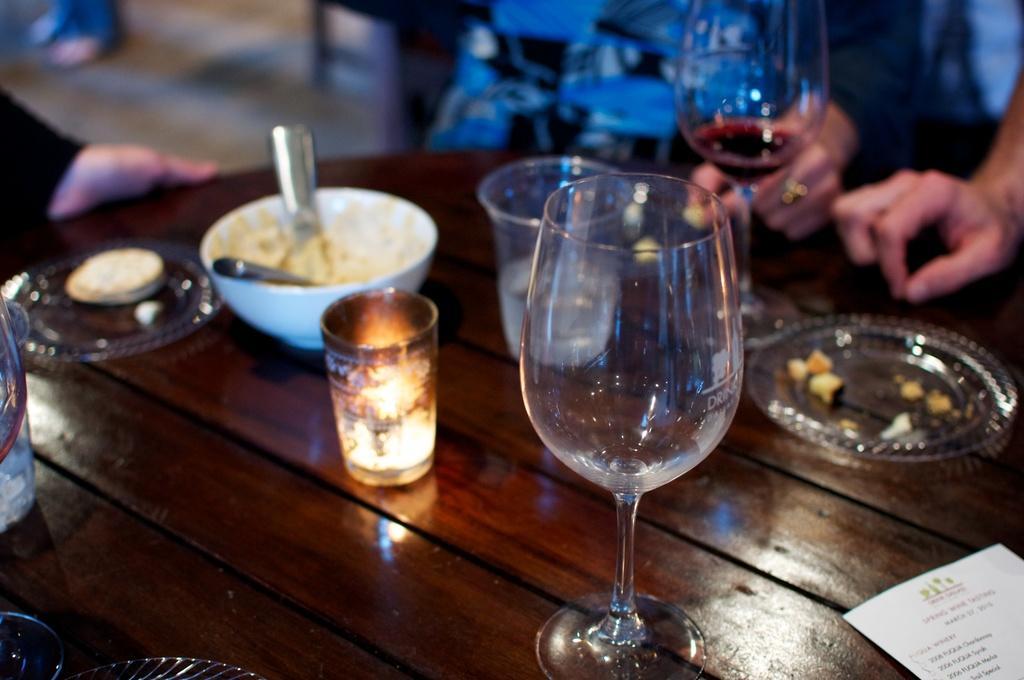Describe this image in one or two sentences. On this table we can able to see plates, bowl, glasses, candle and paper. Beside this table persons are sitting on chair. 